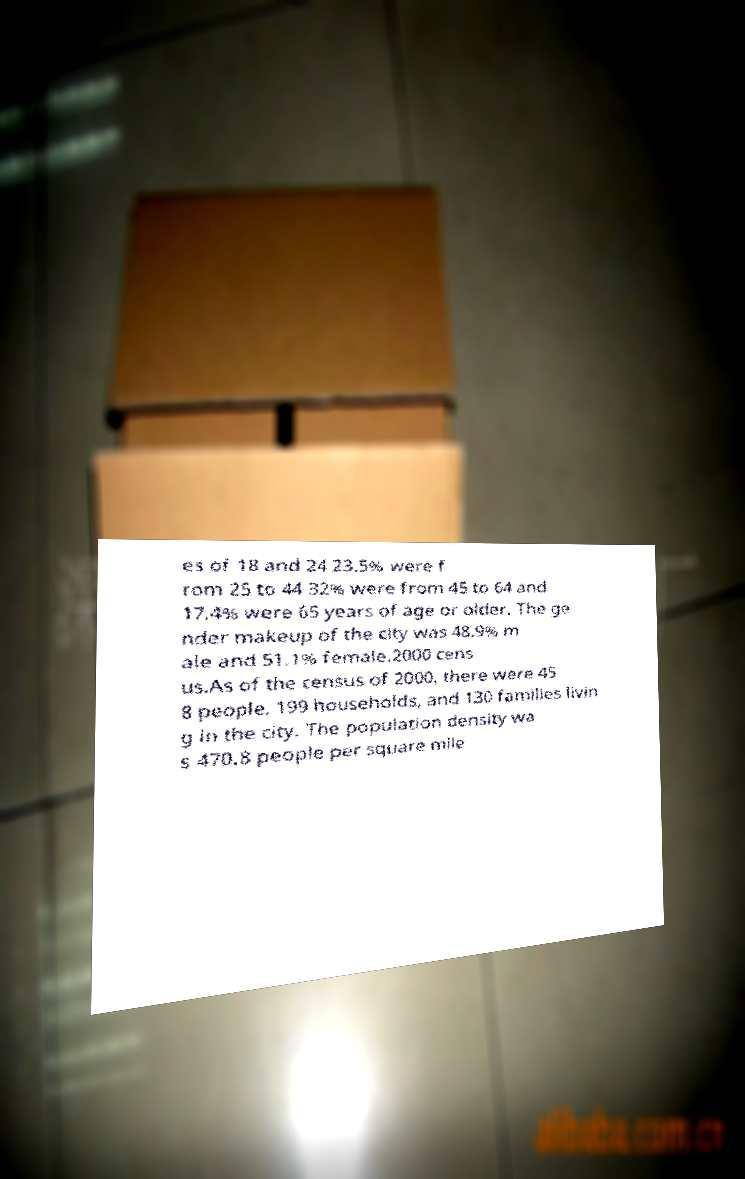What messages or text are displayed in this image? I need them in a readable, typed format. es of 18 and 24 23.5% were f rom 25 to 44 32% were from 45 to 64 and 17.4% were 65 years of age or older. The ge nder makeup of the city was 48.9% m ale and 51.1% female.2000 cens us.As of the census of 2000, there were 45 8 people, 199 households, and 130 families livin g in the city. The population density wa s 470.8 people per square mile 